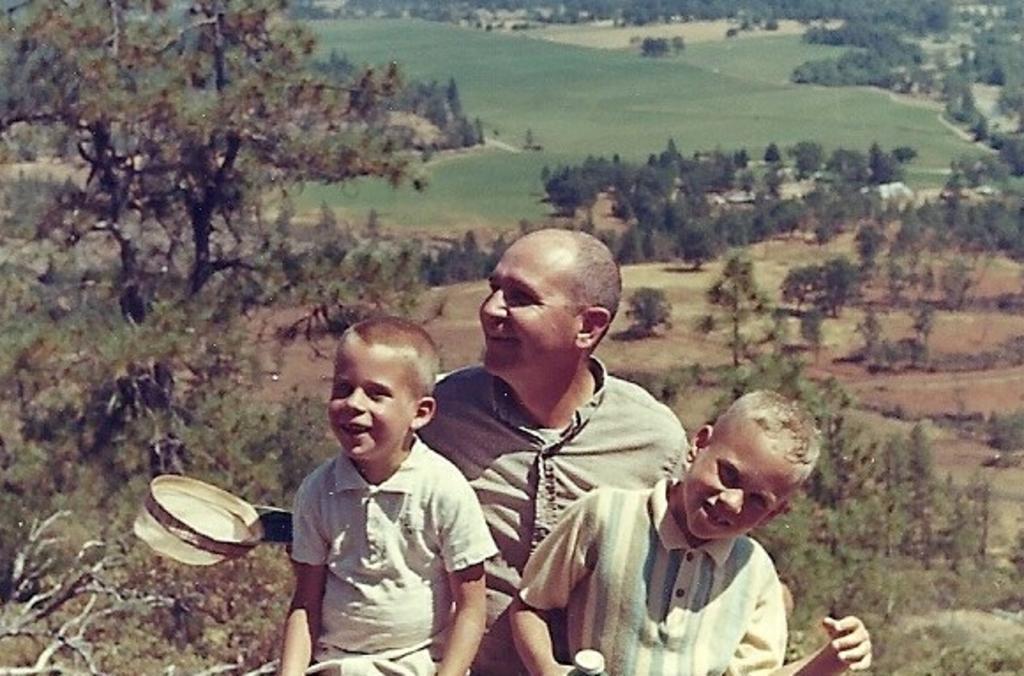In one or two sentences, can you explain what this image depicts? This is an edited image. There are trees in the middle. There are three persons in the middle. One is man and two are kids. They are wearing same color shirts. All are smiling. 